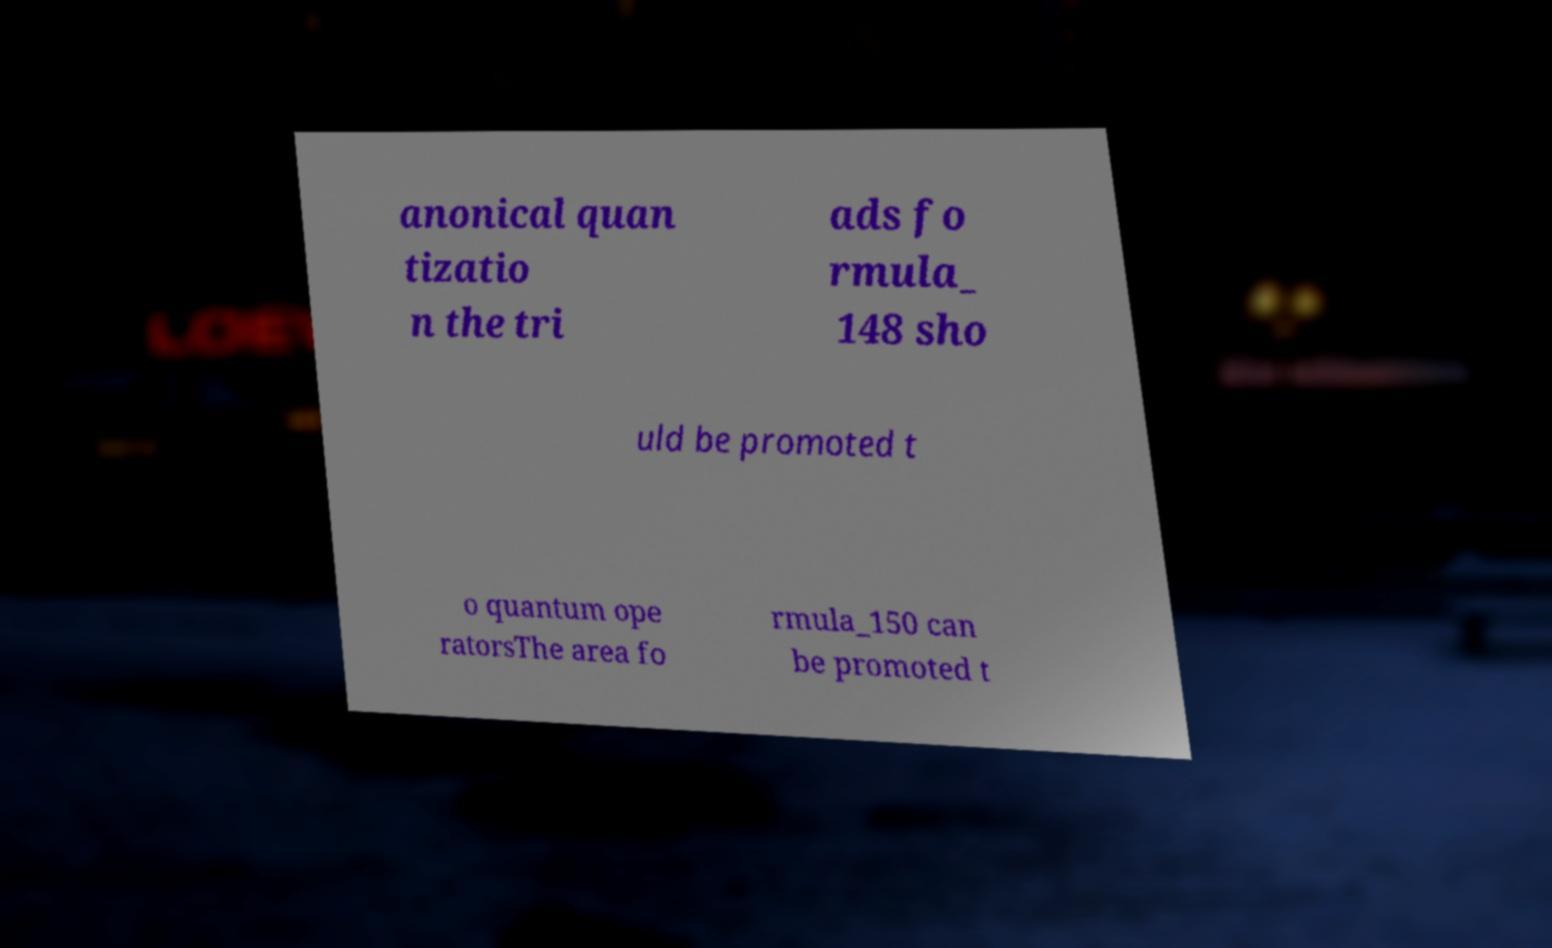There's text embedded in this image that I need extracted. Can you transcribe it verbatim? anonical quan tizatio n the tri ads fo rmula_ 148 sho uld be promoted t o quantum ope ratorsThe area fo rmula_150 can be promoted t 